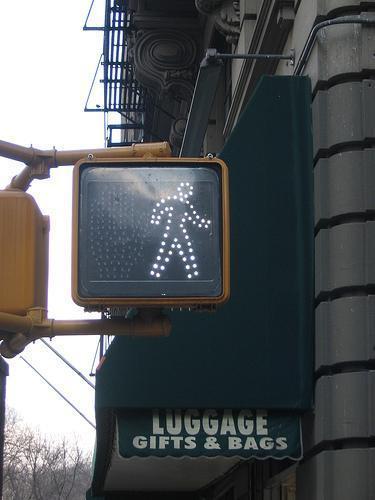How many figures are on the sign?
Give a very brief answer. 1. 